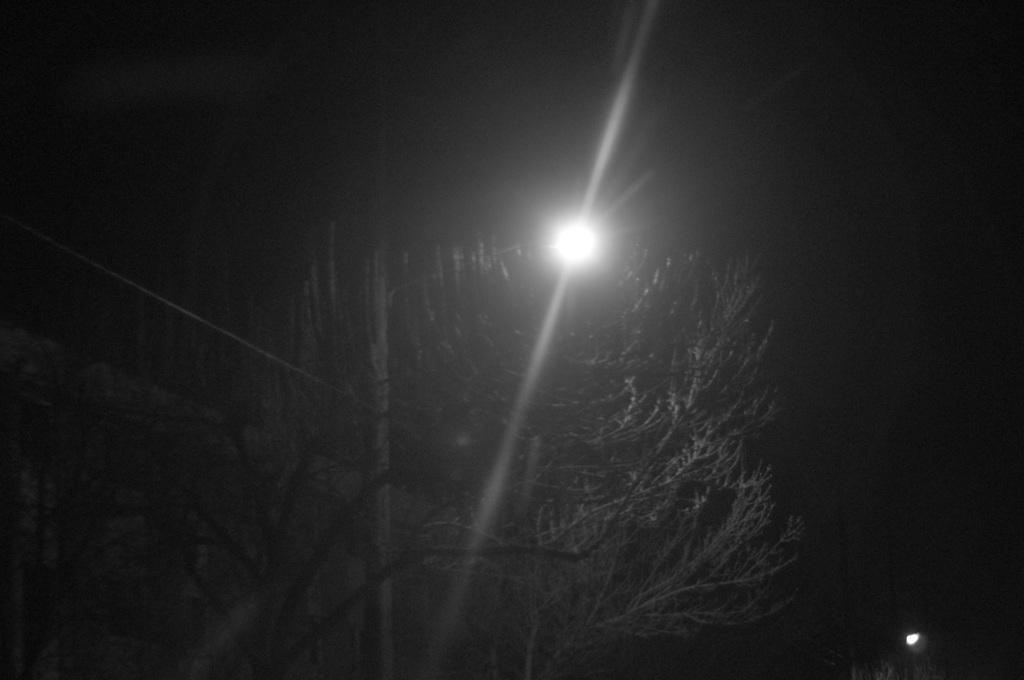Could you give a brief overview of what you see in this image? This image is taken during the night time. In this image we can see the trees and also lights. 